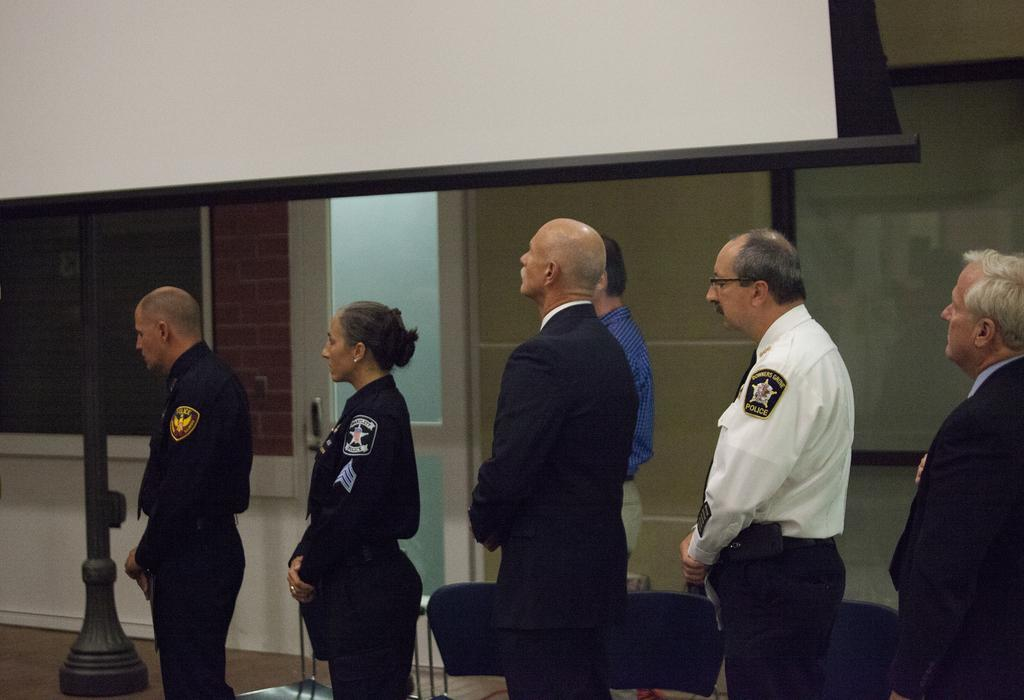What type of people are in the image? There is a group of cops in the image. How are the cops positioned in the image? The cops are standing in a queue. What is located behind the cops? There is a projector screen behind the cops. What is behind the projector screen? There is a wall behind the projector screen. What is beside the wall? There is a window beside the wall. Can you hear the cops laughing in the image? There is no sound present in the image, so it is not possible to determine if the cops are laughing. 